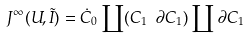Convert formula to latex. <formula><loc_0><loc_0><loc_500><loc_500>J ^ { \infty } ( U , \tilde { I } ) = \dot { C } _ { 0 } \coprod ( C _ { 1 } \ \partial C _ { 1 } ) \coprod \partial C _ { 1 }</formula> 